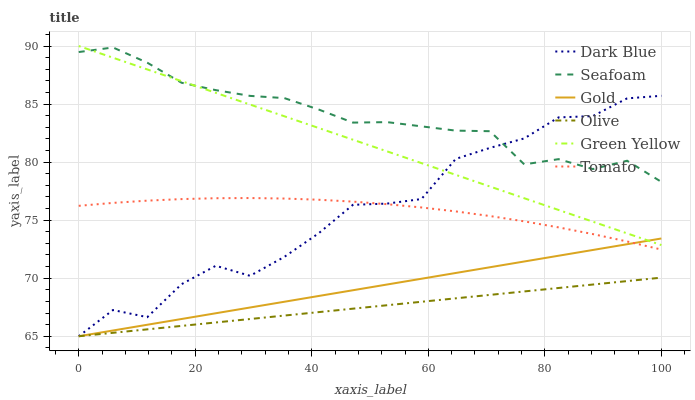Does Olive have the minimum area under the curve?
Answer yes or no. Yes. Does Seafoam have the maximum area under the curve?
Answer yes or no. Yes. Does Gold have the minimum area under the curve?
Answer yes or no. No. Does Gold have the maximum area under the curve?
Answer yes or no. No. Is Green Yellow the smoothest?
Answer yes or no. Yes. Is Dark Blue the roughest?
Answer yes or no. Yes. Is Gold the smoothest?
Answer yes or no. No. Is Gold the roughest?
Answer yes or no. No. Does Gold have the lowest value?
Answer yes or no. Yes. Does Seafoam have the lowest value?
Answer yes or no. No. Does Green Yellow have the highest value?
Answer yes or no. Yes. Does Gold have the highest value?
Answer yes or no. No. Is Olive less than Tomato?
Answer yes or no. Yes. Is Seafoam greater than Gold?
Answer yes or no. Yes. Does Seafoam intersect Dark Blue?
Answer yes or no. Yes. Is Seafoam less than Dark Blue?
Answer yes or no. No. Is Seafoam greater than Dark Blue?
Answer yes or no. No. Does Olive intersect Tomato?
Answer yes or no. No. 